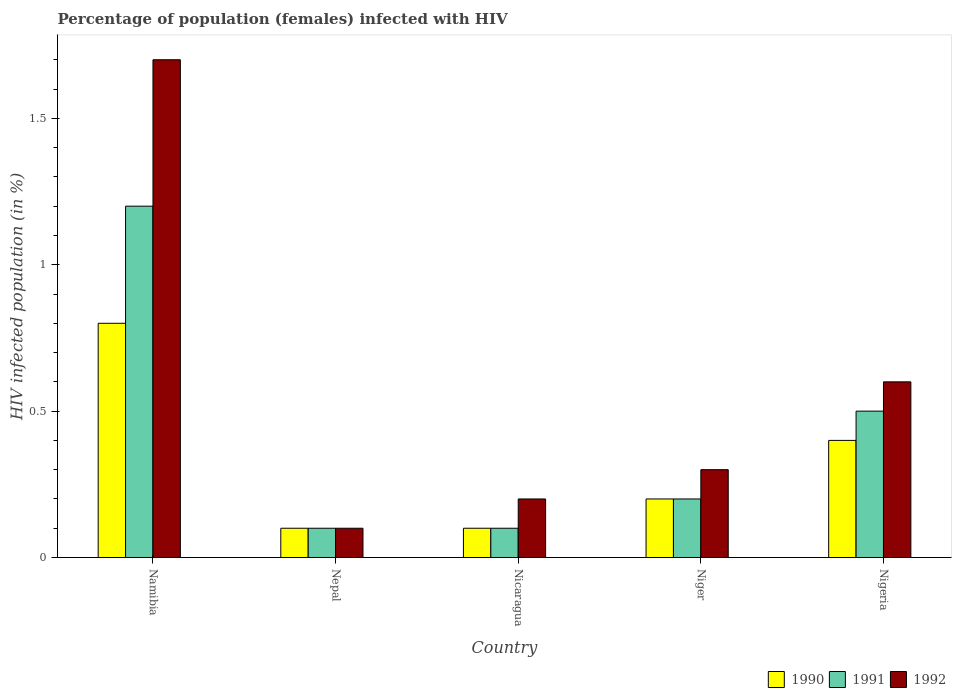How many groups of bars are there?
Provide a short and direct response. 5. Are the number of bars per tick equal to the number of legend labels?
Offer a terse response. Yes. Are the number of bars on each tick of the X-axis equal?
Ensure brevity in your answer.  Yes. How many bars are there on the 1st tick from the left?
Your response must be concise. 3. How many bars are there on the 4th tick from the right?
Your response must be concise. 3. What is the label of the 1st group of bars from the left?
Your answer should be very brief. Namibia. What is the percentage of HIV infected female population in 1991 in Niger?
Your response must be concise. 0.2. In which country was the percentage of HIV infected female population in 1992 maximum?
Offer a very short reply. Namibia. In which country was the percentage of HIV infected female population in 1991 minimum?
Provide a succinct answer. Nepal. What is the total percentage of HIV infected female population in 1992 in the graph?
Your answer should be very brief. 2.9. What is the difference between the percentage of HIV infected female population in 1990 in Nigeria and the percentage of HIV infected female population in 1992 in Namibia?
Make the answer very short. -1.3. What is the average percentage of HIV infected female population in 1990 per country?
Ensure brevity in your answer.  0.32. What is the difference between the percentage of HIV infected female population of/in 1992 and percentage of HIV infected female population of/in 1990 in Namibia?
Your answer should be compact. 0.9. Is the difference between the percentage of HIV infected female population in 1992 in Nicaragua and Nigeria greater than the difference between the percentage of HIV infected female population in 1990 in Nicaragua and Nigeria?
Your answer should be very brief. No. What is the difference between the highest and the lowest percentage of HIV infected female population in 1990?
Offer a terse response. 0.7. In how many countries, is the percentage of HIV infected female population in 1992 greater than the average percentage of HIV infected female population in 1992 taken over all countries?
Make the answer very short. 2. Is the sum of the percentage of HIV infected female population in 1992 in Niger and Nigeria greater than the maximum percentage of HIV infected female population in 1991 across all countries?
Provide a succinct answer. No. Is it the case that in every country, the sum of the percentage of HIV infected female population in 1990 and percentage of HIV infected female population in 1991 is greater than the percentage of HIV infected female population in 1992?
Ensure brevity in your answer.  No. How many countries are there in the graph?
Keep it short and to the point. 5. Does the graph contain grids?
Your answer should be compact. No. How many legend labels are there?
Ensure brevity in your answer.  3. What is the title of the graph?
Give a very brief answer. Percentage of population (females) infected with HIV. What is the label or title of the Y-axis?
Keep it short and to the point. HIV infected population (in %). What is the HIV infected population (in %) in 1992 in Namibia?
Provide a succinct answer. 1.7. What is the HIV infected population (in %) in 1992 in Nicaragua?
Offer a terse response. 0.2. What is the HIV infected population (in %) in 1990 in Niger?
Your answer should be compact. 0.2. What is the HIV infected population (in %) of 1990 in Nigeria?
Give a very brief answer. 0.4. What is the HIV infected population (in %) of 1991 in Nigeria?
Make the answer very short. 0.5. What is the HIV infected population (in %) of 1992 in Nigeria?
Your answer should be compact. 0.6. Across all countries, what is the maximum HIV infected population (in %) of 1990?
Offer a very short reply. 0.8. Across all countries, what is the maximum HIV infected population (in %) of 1992?
Provide a succinct answer. 1.7. Across all countries, what is the minimum HIV infected population (in %) of 1990?
Your answer should be compact. 0.1. Across all countries, what is the minimum HIV infected population (in %) of 1991?
Give a very brief answer. 0.1. Across all countries, what is the minimum HIV infected population (in %) of 1992?
Provide a short and direct response. 0.1. What is the total HIV infected population (in %) in 1990 in the graph?
Keep it short and to the point. 1.6. What is the difference between the HIV infected population (in %) of 1991 in Namibia and that in Nepal?
Ensure brevity in your answer.  1.1. What is the difference between the HIV infected population (in %) of 1991 in Namibia and that in Nicaragua?
Provide a succinct answer. 1.1. What is the difference between the HIV infected population (in %) of 1992 in Namibia and that in Nicaragua?
Provide a succinct answer. 1.5. What is the difference between the HIV infected population (in %) of 1990 in Namibia and that in Niger?
Ensure brevity in your answer.  0.6. What is the difference between the HIV infected population (in %) of 1991 in Namibia and that in Niger?
Offer a very short reply. 1. What is the difference between the HIV infected population (in %) in 1992 in Namibia and that in Niger?
Ensure brevity in your answer.  1.4. What is the difference between the HIV infected population (in %) in 1990 in Namibia and that in Nigeria?
Your answer should be compact. 0.4. What is the difference between the HIV infected population (in %) in 1992 in Nepal and that in Nicaragua?
Offer a terse response. -0.1. What is the difference between the HIV infected population (in %) in 1990 in Nepal and that in Niger?
Ensure brevity in your answer.  -0.1. What is the difference between the HIV infected population (in %) in 1992 in Nepal and that in Nigeria?
Give a very brief answer. -0.5. What is the difference between the HIV infected population (in %) of 1991 in Nicaragua and that in Niger?
Your response must be concise. -0.1. What is the difference between the HIV infected population (in %) in 1992 in Nicaragua and that in Niger?
Provide a short and direct response. -0.1. What is the difference between the HIV infected population (in %) of 1990 in Nicaragua and that in Nigeria?
Keep it short and to the point. -0.3. What is the difference between the HIV infected population (in %) in 1990 in Niger and that in Nigeria?
Ensure brevity in your answer.  -0.2. What is the difference between the HIV infected population (in %) of 1990 in Namibia and the HIV infected population (in %) of 1991 in Nepal?
Give a very brief answer. 0.7. What is the difference between the HIV infected population (in %) of 1990 in Namibia and the HIV infected population (in %) of 1992 in Nepal?
Give a very brief answer. 0.7. What is the difference between the HIV infected population (in %) in 1991 in Namibia and the HIV infected population (in %) in 1992 in Nepal?
Give a very brief answer. 1.1. What is the difference between the HIV infected population (in %) in 1990 in Namibia and the HIV infected population (in %) in 1991 in Nicaragua?
Offer a terse response. 0.7. What is the difference between the HIV infected population (in %) of 1990 in Namibia and the HIV infected population (in %) of 1991 in Niger?
Make the answer very short. 0.6. What is the difference between the HIV infected population (in %) in 1991 in Namibia and the HIV infected population (in %) in 1992 in Niger?
Provide a short and direct response. 0.9. What is the difference between the HIV infected population (in %) of 1990 in Namibia and the HIV infected population (in %) of 1991 in Nigeria?
Provide a short and direct response. 0.3. What is the difference between the HIV infected population (in %) in 1990 in Namibia and the HIV infected population (in %) in 1992 in Nigeria?
Give a very brief answer. 0.2. What is the difference between the HIV infected population (in %) in 1990 in Nepal and the HIV infected population (in %) in 1992 in Niger?
Your answer should be compact. -0.2. What is the difference between the HIV infected population (in %) in 1991 in Nepal and the HIV infected population (in %) in 1992 in Niger?
Provide a succinct answer. -0.2. What is the difference between the HIV infected population (in %) of 1990 in Nepal and the HIV infected population (in %) of 1991 in Nigeria?
Provide a succinct answer. -0.4. What is the difference between the HIV infected population (in %) in 1991 in Nepal and the HIV infected population (in %) in 1992 in Nigeria?
Provide a succinct answer. -0.5. What is the difference between the HIV infected population (in %) in 1990 in Nicaragua and the HIV infected population (in %) in 1991 in Niger?
Provide a short and direct response. -0.1. What is the difference between the HIV infected population (in %) in 1990 in Nicaragua and the HIV infected population (in %) in 1992 in Nigeria?
Make the answer very short. -0.5. What is the difference between the HIV infected population (in %) of 1991 in Niger and the HIV infected population (in %) of 1992 in Nigeria?
Your response must be concise. -0.4. What is the average HIV infected population (in %) of 1990 per country?
Make the answer very short. 0.32. What is the average HIV infected population (in %) in 1991 per country?
Keep it short and to the point. 0.42. What is the average HIV infected population (in %) of 1992 per country?
Your answer should be very brief. 0.58. What is the difference between the HIV infected population (in %) of 1990 and HIV infected population (in %) of 1991 in Namibia?
Your answer should be very brief. -0.4. What is the difference between the HIV infected population (in %) in 1991 and HIV infected population (in %) in 1992 in Namibia?
Provide a short and direct response. -0.5. What is the difference between the HIV infected population (in %) in 1990 and HIV infected population (in %) in 1991 in Nepal?
Your answer should be very brief. 0. What is the difference between the HIV infected population (in %) of 1991 and HIV infected population (in %) of 1992 in Nicaragua?
Your answer should be very brief. -0.1. What is the difference between the HIV infected population (in %) of 1990 and HIV infected population (in %) of 1991 in Niger?
Provide a short and direct response. 0. What is the difference between the HIV infected population (in %) of 1990 and HIV infected population (in %) of 1992 in Niger?
Offer a terse response. -0.1. What is the difference between the HIV infected population (in %) of 1990 and HIV infected population (in %) of 1991 in Nigeria?
Ensure brevity in your answer.  -0.1. What is the difference between the HIV infected population (in %) in 1991 and HIV infected population (in %) in 1992 in Nigeria?
Offer a very short reply. -0.1. What is the ratio of the HIV infected population (in %) of 1990 in Namibia to that in Nepal?
Ensure brevity in your answer.  8. What is the ratio of the HIV infected population (in %) in 1991 in Namibia to that in Nepal?
Provide a succinct answer. 12. What is the ratio of the HIV infected population (in %) in 1992 in Namibia to that in Nepal?
Provide a succinct answer. 17. What is the ratio of the HIV infected population (in %) of 1990 in Namibia to that in Nicaragua?
Offer a terse response. 8. What is the ratio of the HIV infected population (in %) of 1991 in Namibia to that in Nicaragua?
Offer a terse response. 12. What is the ratio of the HIV infected population (in %) of 1990 in Namibia to that in Niger?
Provide a short and direct response. 4. What is the ratio of the HIV infected population (in %) of 1991 in Namibia to that in Niger?
Offer a very short reply. 6. What is the ratio of the HIV infected population (in %) of 1992 in Namibia to that in Niger?
Your answer should be very brief. 5.67. What is the ratio of the HIV infected population (in %) of 1991 in Namibia to that in Nigeria?
Your response must be concise. 2.4. What is the ratio of the HIV infected population (in %) in 1992 in Namibia to that in Nigeria?
Ensure brevity in your answer.  2.83. What is the ratio of the HIV infected population (in %) in 1992 in Nepal to that in Nicaragua?
Your answer should be very brief. 0.5. What is the ratio of the HIV infected population (in %) of 1991 in Nepal to that in Niger?
Give a very brief answer. 0.5. What is the ratio of the HIV infected population (in %) of 1992 in Nepal to that in Niger?
Keep it short and to the point. 0.33. What is the ratio of the HIV infected population (in %) of 1991 in Nepal to that in Nigeria?
Your response must be concise. 0.2. What is the ratio of the HIV infected population (in %) of 1990 in Nicaragua to that in Niger?
Provide a short and direct response. 0.5. What is the ratio of the HIV infected population (in %) of 1991 in Nicaragua to that in Niger?
Offer a very short reply. 0.5. What is the ratio of the HIV infected population (in %) of 1992 in Nicaragua to that in Niger?
Provide a succinct answer. 0.67. What is the ratio of the HIV infected population (in %) of 1990 in Niger to that in Nigeria?
Your answer should be very brief. 0.5. What is the difference between the highest and the second highest HIV infected population (in %) of 1990?
Your answer should be compact. 0.4. What is the difference between the highest and the lowest HIV infected population (in %) of 1991?
Keep it short and to the point. 1.1. 